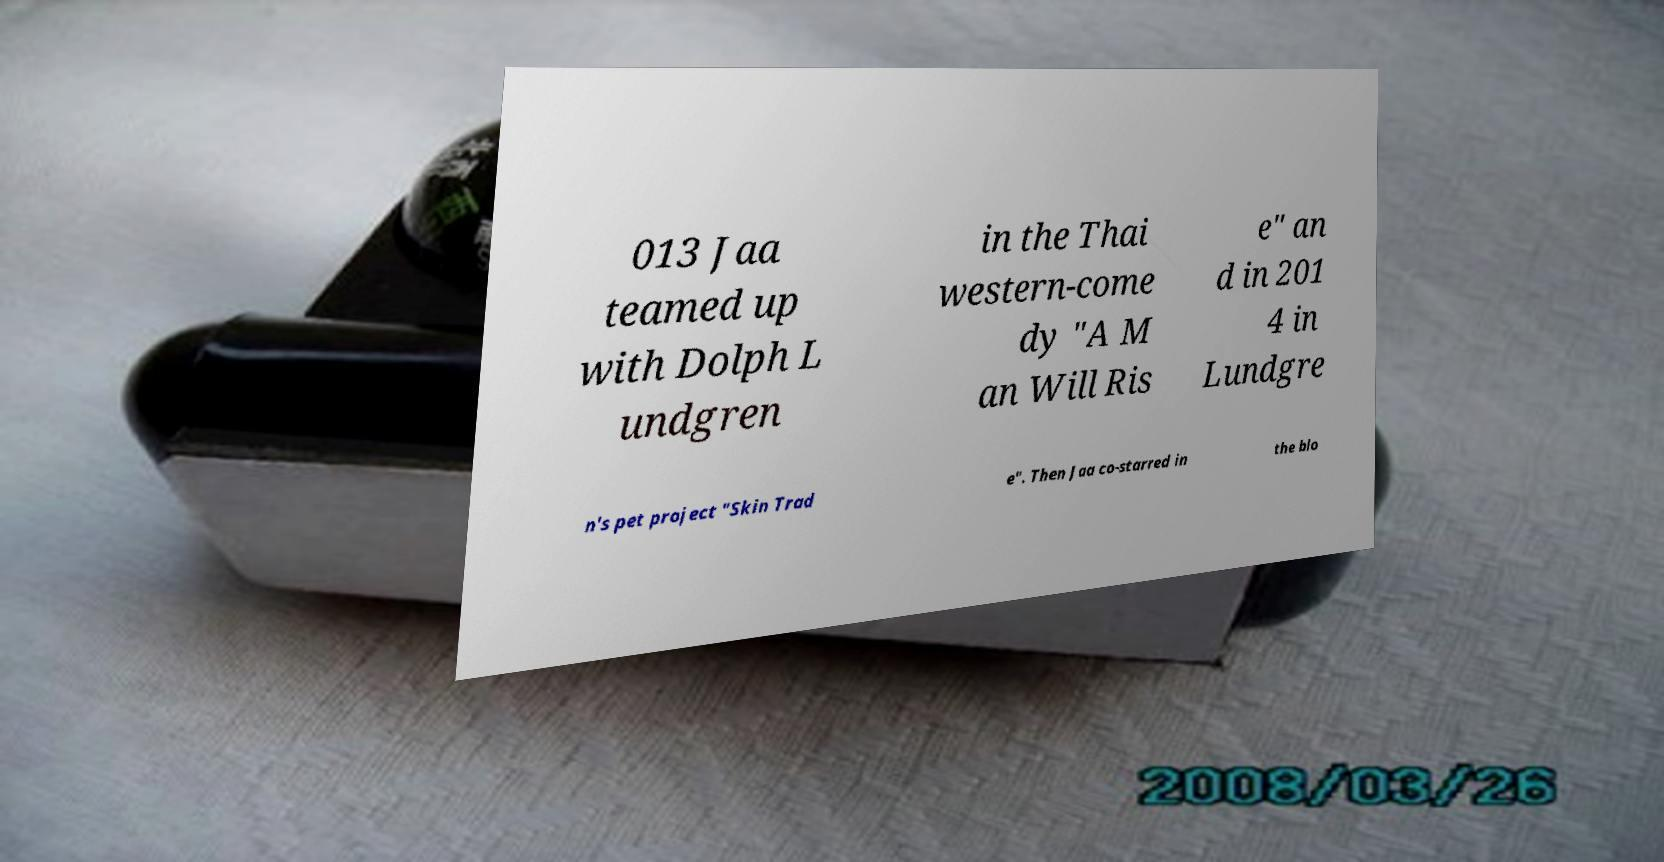What messages or text are displayed in this image? I need them in a readable, typed format. 013 Jaa teamed up with Dolph L undgren in the Thai western-come dy "A M an Will Ris e" an d in 201 4 in Lundgre n's pet project "Skin Trad e". Then Jaa co-starred in the blo 